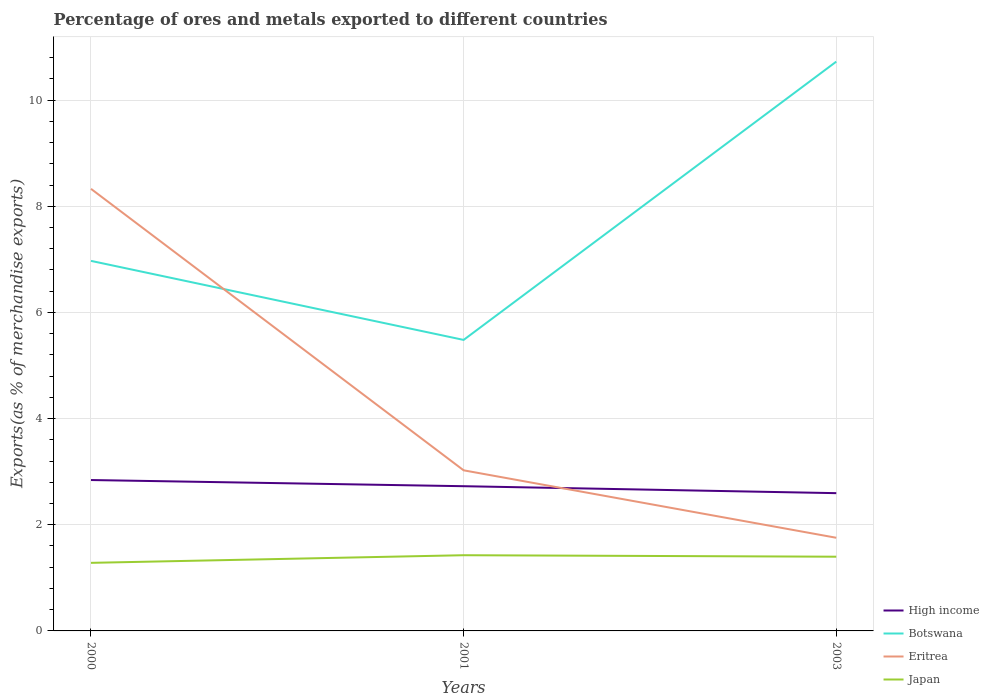How many different coloured lines are there?
Provide a short and direct response. 4. Across all years, what is the maximum percentage of exports to different countries in Japan?
Your answer should be compact. 1.28. In which year was the percentage of exports to different countries in High income maximum?
Give a very brief answer. 2003. What is the total percentage of exports to different countries in Eritrea in the graph?
Offer a terse response. 6.57. What is the difference between the highest and the second highest percentage of exports to different countries in High income?
Your response must be concise. 0.25. Is the percentage of exports to different countries in Eritrea strictly greater than the percentage of exports to different countries in Botswana over the years?
Your answer should be compact. No. How many lines are there?
Your response must be concise. 4. How many years are there in the graph?
Keep it short and to the point. 3. What is the difference between two consecutive major ticks on the Y-axis?
Provide a succinct answer. 2. Are the values on the major ticks of Y-axis written in scientific E-notation?
Keep it short and to the point. No. Does the graph contain any zero values?
Keep it short and to the point. No. How many legend labels are there?
Make the answer very short. 4. What is the title of the graph?
Keep it short and to the point. Percentage of ores and metals exported to different countries. What is the label or title of the X-axis?
Offer a terse response. Years. What is the label or title of the Y-axis?
Give a very brief answer. Exports(as % of merchandise exports). What is the Exports(as % of merchandise exports) in High income in 2000?
Ensure brevity in your answer.  2.84. What is the Exports(as % of merchandise exports) in Botswana in 2000?
Give a very brief answer. 6.97. What is the Exports(as % of merchandise exports) in Eritrea in 2000?
Provide a succinct answer. 8.33. What is the Exports(as % of merchandise exports) in Japan in 2000?
Keep it short and to the point. 1.28. What is the Exports(as % of merchandise exports) of High income in 2001?
Provide a succinct answer. 2.73. What is the Exports(as % of merchandise exports) in Botswana in 2001?
Make the answer very short. 5.48. What is the Exports(as % of merchandise exports) of Eritrea in 2001?
Your answer should be compact. 3.03. What is the Exports(as % of merchandise exports) in Japan in 2001?
Offer a terse response. 1.43. What is the Exports(as % of merchandise exports) of High income in 2003?
Offer a terse response. 2.6. What is the Exports(as % of merchandise exports) in Botswana in 2003?
Give a very brief answer. 10.72. What is the Exports(as % of merchandise exports) of Eritrea in 2003?
Give a very brief answer. 1.75. What is the Exports(as % of merchandise exports) of Japan in 2003?
Give a very brief answer. 1.4. Across all years, what is the maximum Exports(as % of merchandise exports) in High income?
Provide a succinct answer. 2.84. Across all years, what is the maximum Exports(as % of merchandise exports) in Botswana?
Provide a succinct answer. 10.72. Across all years, what is the maximum Exports(as % of merchandise exports) of Eritrea?
Keep it short and to the point. 8.33. Across all years, what is the maximum Exports(as % of merchandise exports) in Japan?
Offer a terse response. 1.43. Across all years, what is the minimum Exports(as % of merchandise exports) of High income?
Offer a very short reply. 2.6. Across all years, what is the minimum Exports(as % of merchandise exports) of Botswana?
Your answer should be very brief. 5.48. Across all years, what is the minimum Exports(as % of merchandise exports) of Eritrea?
Your answer should be compact. 1.75. Across all years, what is the minimum Exports(as % of merchandise exports) of Japan?
Provide a succinct answer. 1.28. What is the total Exports(as % of merchandise exports) of High income in the graph?
Your response must be concise. 8.16. What is the total Exports(as % of merchandise exports) of Botswana in the graph?
Your answer should be very brief. 23.18. What is the total Exports(as % of merchandise exports) of Eritrea in the graph?
Your answer should be very brief. 13.11. What is the total Exports(as % of merchandise exports) of Japan in the graph?
Give a very brief answer. 4.11. What is the difference between the Exports(as % of merchandise exports) in High income in 2000 and that in 2001?
Your response must be concise. 0.12. What is the difference between the Exports(as % of merchandise exports) in Botswana in 2000 and that in 2001?
Provide a succinct answer. 1.49. What is the difference between the Exports(as % of merchandise exports) of Eritrea in 2000 and that in 2001?
Keep it short and to the point. 5.3. What is the difference between the Exports(as % of merchandise exports) in Japan in 2000 and that in 2001?
Your answer should be very brief. -0.14. What is the difference between the Exports(as % of merchandise exports) of High income in 2000 and that in 2003?
Ensure brevity in your answer.  0.25. What is the difference between the Exports(as % of merchandise exports) in Botswana in 2000 and that in 2003?
Provide a succinct answer. -3.75. What is the difference between the Exports(as % of merchandise exports) in Eritrea in 2000 and that in 2003?
Offer a very short reply. 6.57. What is the difference between the Exports(as % of merchandise exports) of Japan in 2000 and that in 2003?
Offer a very short reply. -0.12. What is the difference between the Exports(as % of merchandise exports) of High income in 2001 and that in 2003?
Provide a short and direct response. 0.13. What is the difference between the Exports(as % of merchandise exports) in Botswana in 2001 and that in 2003?
Keep it short and to the point. -5.24. What is the difference between the Exports(as % of merchandise exports) in Eritrea in 2001 and that in 2003?
Provide a succinct answer. 1.27. What is the difference between the Exports(as % of merchandise exports) in Japan in 2001 and that in 2003?
Offer a very short reply. 0.03. What is the difference between the Exports(as % of merchandise exports) of High income in 2000 and the Exports(as % of merchandise exports) of Botswana in 2001?
Offer a terse response. -2.64. What is the difference between the Exports(as % of merchandise exports) of High income in 2000 and the Exports(as % of merchandise exports) of Eritrea in 2001?
Your answer should be very brief. -0.18. What is the difference between the Exports(as % of merchandise exports) in High income in 2000 and the Exports(as % of merchandise exports) in Japan in 2001?
Your answer should be very brief. 1.42. What is the difference between the Exports(as % of merchandise exports) in Botswana in 2000 and the Exports(as % of merchandise exports) in Eritrea in 2001?
Ensure brevity in your answer.  3.95. What is the difference between the Exports(as % of merchandise exports) in Botswana in 2000 and the Exports(as % of merchandise exports) in Japan in 2001?
Make the answer very short. 5.54. What is the difference between the Exports(as % of merchandise exports) in Eritrea in 2000 and the Exports(as % of merchandise exports) in Japan in 2001?
Your answer should be compact. 6.9. What is the difference between the Exports(as % of merchandise exports) in High income in 2000 and the Exports(as % of merchandise exports) in Botswana in 2003?
Your answer should be compact. -7.88. What is the difference between the Exports(as % of merchandise exports) of High income in 2000 and the Exports(as % of merchandise exports) of Eritrea in 2003?
Give a very brief answer. 1.09. What is the difference between the Exports(as % of merchandise exports) of High income in 2000 and the Exports(as % of merchandise exports) of Japan in 2003?
Offer a very short reply. 1.44. What is the difference between the Exports(as % of merchandise exports) of Botswana in 2000 and the Exports(as % of merchandise exports) of Eritrea in 2003?
Give a very brief answer. 5.22. What is the difference between the Exports(as % of merchandise exports) of Botswana in 2000 and the Exports(as % of merchandise exports) of Japan in 2003?
Your response must be concise. 5.57. What is the difference between the Exports(as % of merchandise exports) in Eritrea in 2000 and the Exports(as % of merchandise exports) in Japan in 2003?
Give a very brief answer. 6.93. What is the difference between the Exports(as % of merchandise exports) of High income in 2001 and the Exports(as % of merchandise exports) of Botswana in 2003?
Ensure brevity in your answer.  -8. What is the difference between the Exports(as % of merchandise exports) of High income in 2001 and the Exports(as % of merchandise exports) of Eritrea in 2003?
Your answer should be very brief. 0.97. What is the difference between the Exports(as % of merchandise exports) in High income in 2001 and the Exports(as % of merchandise exports) in Japan in 2003?
Offer a terse response. 1.33. What is the difference between the Exports(as % of merchandise exports) of Botswana in 2001 and the Exports(as % of merchandise exports) of Eritrea in 2003?
Your answer should be compact. 3.73. What is the difference between the Exports(as % of merchandise exports) of Botswana in 2001 and the Exports(as % of merchandise exports) of Japan in 2003?
Keep it short and to the point. 4.08. What is the difference between the Exports(as % of merchandise exports) of Eritrea in 2001 and the Exports(as % of merchandise exports) of Japan in 2003?
Make the answer very short. 1.63. What is the average Exports(as % of merchandise exports) in High income per year?
Ensure brevity in your answer.  2.72. What is the average Exports(as % of merchandise exports) in Botswana per year?
Provide a succinct answer. 7.73. What is the average Exports(as % of merchandise exports) of Eritrea per year?
Provide a short and direct response. 4.37. What is the average Exports(as % of merchandise exports) of Japan per year?
Make the answer very short. 1.37. In the year 2000, what is the difference between the Exports(as % of merchandise exports) in High income and Exports(as % of merchandise exports) in Botswana?
Your response must be concise. -4.13. In the year 2000, what is the difference between the Exports(as % of merchandise exports) in High income and Exports(as % of merchandise exports) in Eritrea?
Provide a succinct answer. -5.49. In the year 2000, what is the difference between the Exports(as % of merchandise exports) of High income and Exports(as % of merchandise exports) of Japan?
Provide a short and direct response. 1.56. In the year 2000, what is the difference between the Exports(as % of merchandise exports) of Botswana and Exports(as % of merchandise exports) of Eritrea?
Offer a terse response. -1.36. In the year 2000, what is the difference between the Exports(as % of merchandise exports) of Botswana and Exports(as % of merchandise exports) of Japan?
Provide a succinct answer. 5.69. In the year 2000, what is the difference between the Exports(as % of merchandise exports) of Eritrea and Exports(as % of merchandise exports) of Japan?
Your answer should be compact. 7.05. In the year 2001, what is the difference between the Exports(as % of merchandise exports) of High income and Exports(as % of merchandise exports) of Botswana?
Offer a very short reply. -2.76. In the year 2001, what is the difference between the Exports(as % of merchandise exports) in High income and Exports(as % of merchandise exports) in Eritrea?
Your response must be concise. -0.3. In the year 2001, what is the difference between the Exports(as % of merchandise exports) in Botswana and Exports(as % of merchandise exports) in Eritrea?
Your response must be concise. 2.46. In the year 2001, what is the difference between the Exports(as % of merchandise exports) of Botswana and Exports(as % of merchandise exports) of Japan?
Make the answer very short. 4.06. In the year 2001, what is the difference between the Exports(as % of merchandise exports) in Eritrea and Exports(as % of merchandise exports) in Japan?
Make the answer very short. 1.6. In the year 2003, what is the difference between the Exports(as % of merchandise exports) of High income and Exports(as % of merchandise exports) of Botswana?
Offer a very short reply. -8.13. In the year 2003, what is the difference between the Exports(as % of merchandise exports) in High income and Exports(as % of merchandise exports) in Eritrea?
Offer a terse response. 0.84. In the year 2003, what is the difference between the Exports(as % of merchandise exports) in High income and Exports(as % of merchandise exports) in Japan?
Give a very brief answer. 1.2. In the year 2003, what is the difference between the Exports(as % of merchandise exports) of Botswana and Exports(as % of merchandise exports) of Eritrea?
Ensure brevity in your answer.  8.97. In the year 2003, what is the difference between the Exports(as % of merchandise exports) of Botswana and Exports(as % of merchandise exports) of Japan?
Give a very brief answer. 9.33. In the year 2003, what is the difference between the Exports(as % of merchandise exports) in Eritrea and Exports(as % of merchandise exports) in Japan?
Your answer should be compact. 0.36. What is the ratio of the Exports(as % of merchandise exports) in High income in 2000 to that in 2001?
Provide a succinct answer. 1.04. What is the ratio of the Exports(as % of merchandise exports) in Botswana in 2000 to that in 2001?
Ensure brevity in your answer.  1.27. What is the ratio of the Exports(as % of merchandise exports) in Eritrea in 2000 to that in 2001?
Give a very brief answer. 2.75. What is the ratio of the Exports(as % of merchandise exports) of Japan in 2000 to that in 2001?
Make the answer very short. 0.9. What is the ratio of the Exports(as % of merchandise exports) of High income in 2000 to that in 2003?
Make the answer very short. 1.1. What is the ratio of the Exports(as % of merchandise exports) of Botswana in 2000 to that in 2003?
Make the answer very short. 0.65. What is the ratio of the Exports(as % of merchandise exports) in Eritrea in 2000 to that in 2003?
Your answer should be compact. 4.75. What is the ratio of the Exports(as % of merchandise exports) of Japan in 2000 to that in 2003?
Your answer should be very brief. 0.92. What is the ratio of the Exports(as % of merchandise exports) of High income in 2001 to that in 2003?
Provide a succinct answer. 1.05. What is the ratio of the Exports(as % of merchandise exports) in Botswana in 2001 to that in 2003?
Provide a short and direct response. 0.51. What is the ratio of the Exports(as % of merchandise exports) in Eritrea in 2001 to that in 2003?
Offer a terse response. 1.72. What is the ratio of the Exports(as % of merchandise exports) of Japan in 2001 to that in 2003?
Keep it short and to the point. 1.02. What is the difference between the highest and the second highest Exports(as % of merchandise exports) of High income?
Make the answer very short. 0.12. What is the difference between the highest and the second highest Exports(as % of merchandise exports) of Botswana?
Provide a succinct answer. 3.75. What is the difference between the highest and the second highest Exports(as % of merchandise exports) of Eritrea?
Provide a short and direct response. 5.3. What is the difference between the highest and the second highest Exports(as % of merchandise exports) in Japan?
Provide a short and direct response. 0.03. What is the difference between the highest and the lowest Exports(as % of merchandise exports) of High income?
Keep it short and to the point. 0.25. What is the difference between the highest and the lowest Exports(as % of merchandise exports) of Botswana?
Provide a short and direct response. 5.24. What is the difference between the highest and the lowest Exports(as % of merchandise exports) of Eritrea?
Your answer should be very brief. 6.57. What is the difference between the highest and the lowest Exports(as % of merchandise exports) of Japan?
Make the answer very short. 0.14. 